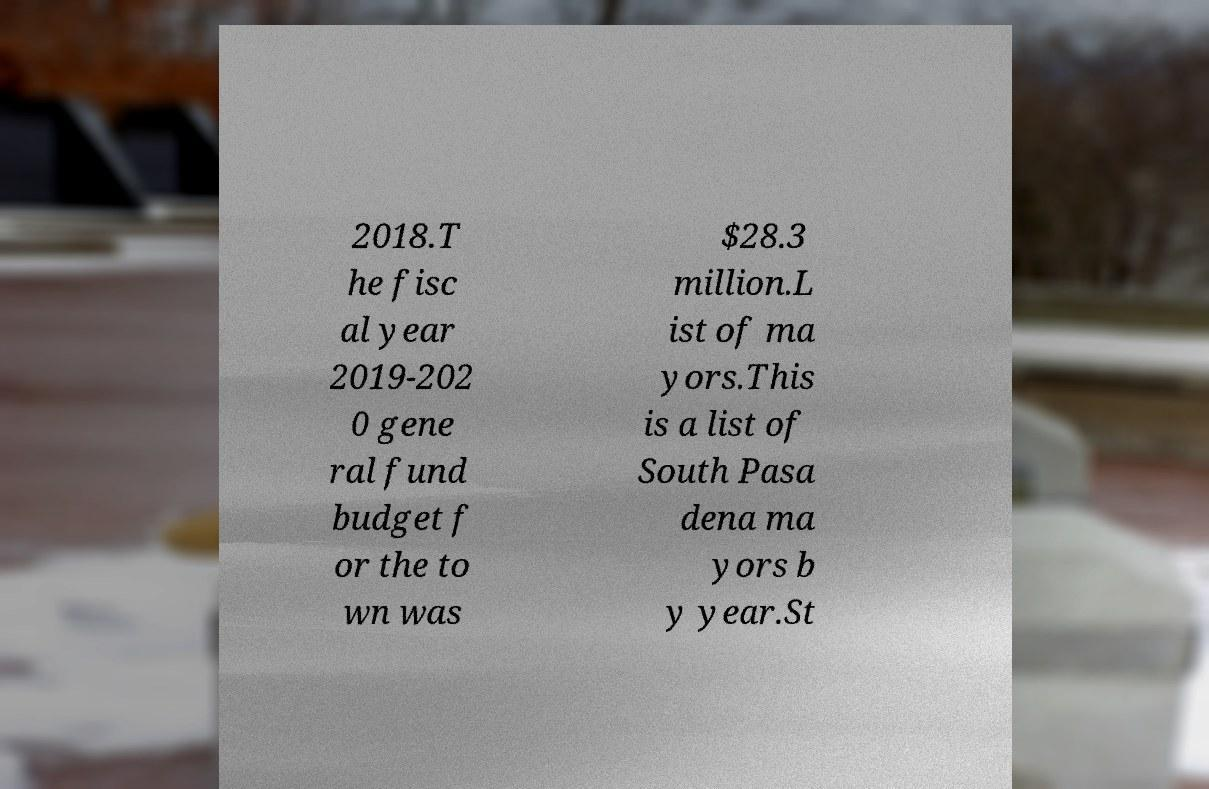There's text embedded in this image that I need extracted. Can you transcribe it verbatim? 2018.T he fisc al year 2019-202 0 gene ral fund budget f or the to wn was $28.3 million.L ist of ma yors.This is a list of South Pasa dena ma yors b y year.St 